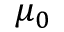<formula> <loc_0><loc_0><loc_500><loc_500>\mu _ { 0 }</formula> 